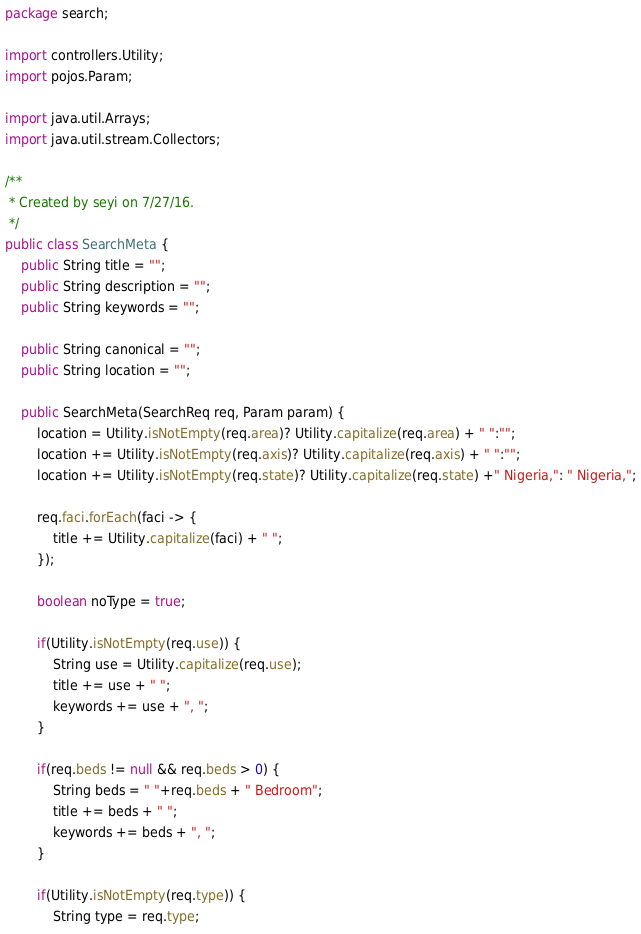<code> <loc_0><loc_0><loc_500><loc_500><_Java_>package search;

import controllers.Utility;
import pojos.Param;

import java.util.Arrays;
import java.util.stream.Collectors;

/**
 * Created by seyi on 7/27/16.
 */
public class SearchMeta {
    public String title = "";
    public String description = "";
    public String keywords = "";

    public String canonical = "";
    public String location = "";

    public SearchMeta(SearchReq req, Param param) {
        location = Utility.isNotEmpty(req.area)? Utility.capitalize(req.area) + " ":"";
        location += Utility.isNotEmpty(req.axis)? Utility.capitalize(req.axis) + " ":"";
        location += Utility.isNotEmpty(req.state)? Utility.capitalize(req.state) +" Nigeria,": " Nigeria,";

        req.faci.forEach(faci -> {
            title += Utility.capitalize(faci) + " ";
        });

        boolean noType = true;

        if(Utility.isNotEmpty(req.use)) {
            String use = Utility.capitalize(req.use);
            title += use + " ";
            keywords += use + ", ";
        }

        if(req.beds != null && req.beds > 0) {
            String beds = " "+req.beds + " Bedroom";
            title += beds + " ";
            keywords += beds + ", ";
        }

        if(Utility.isNotEmpty(req.type)) {
            String type = req.type;</code> 